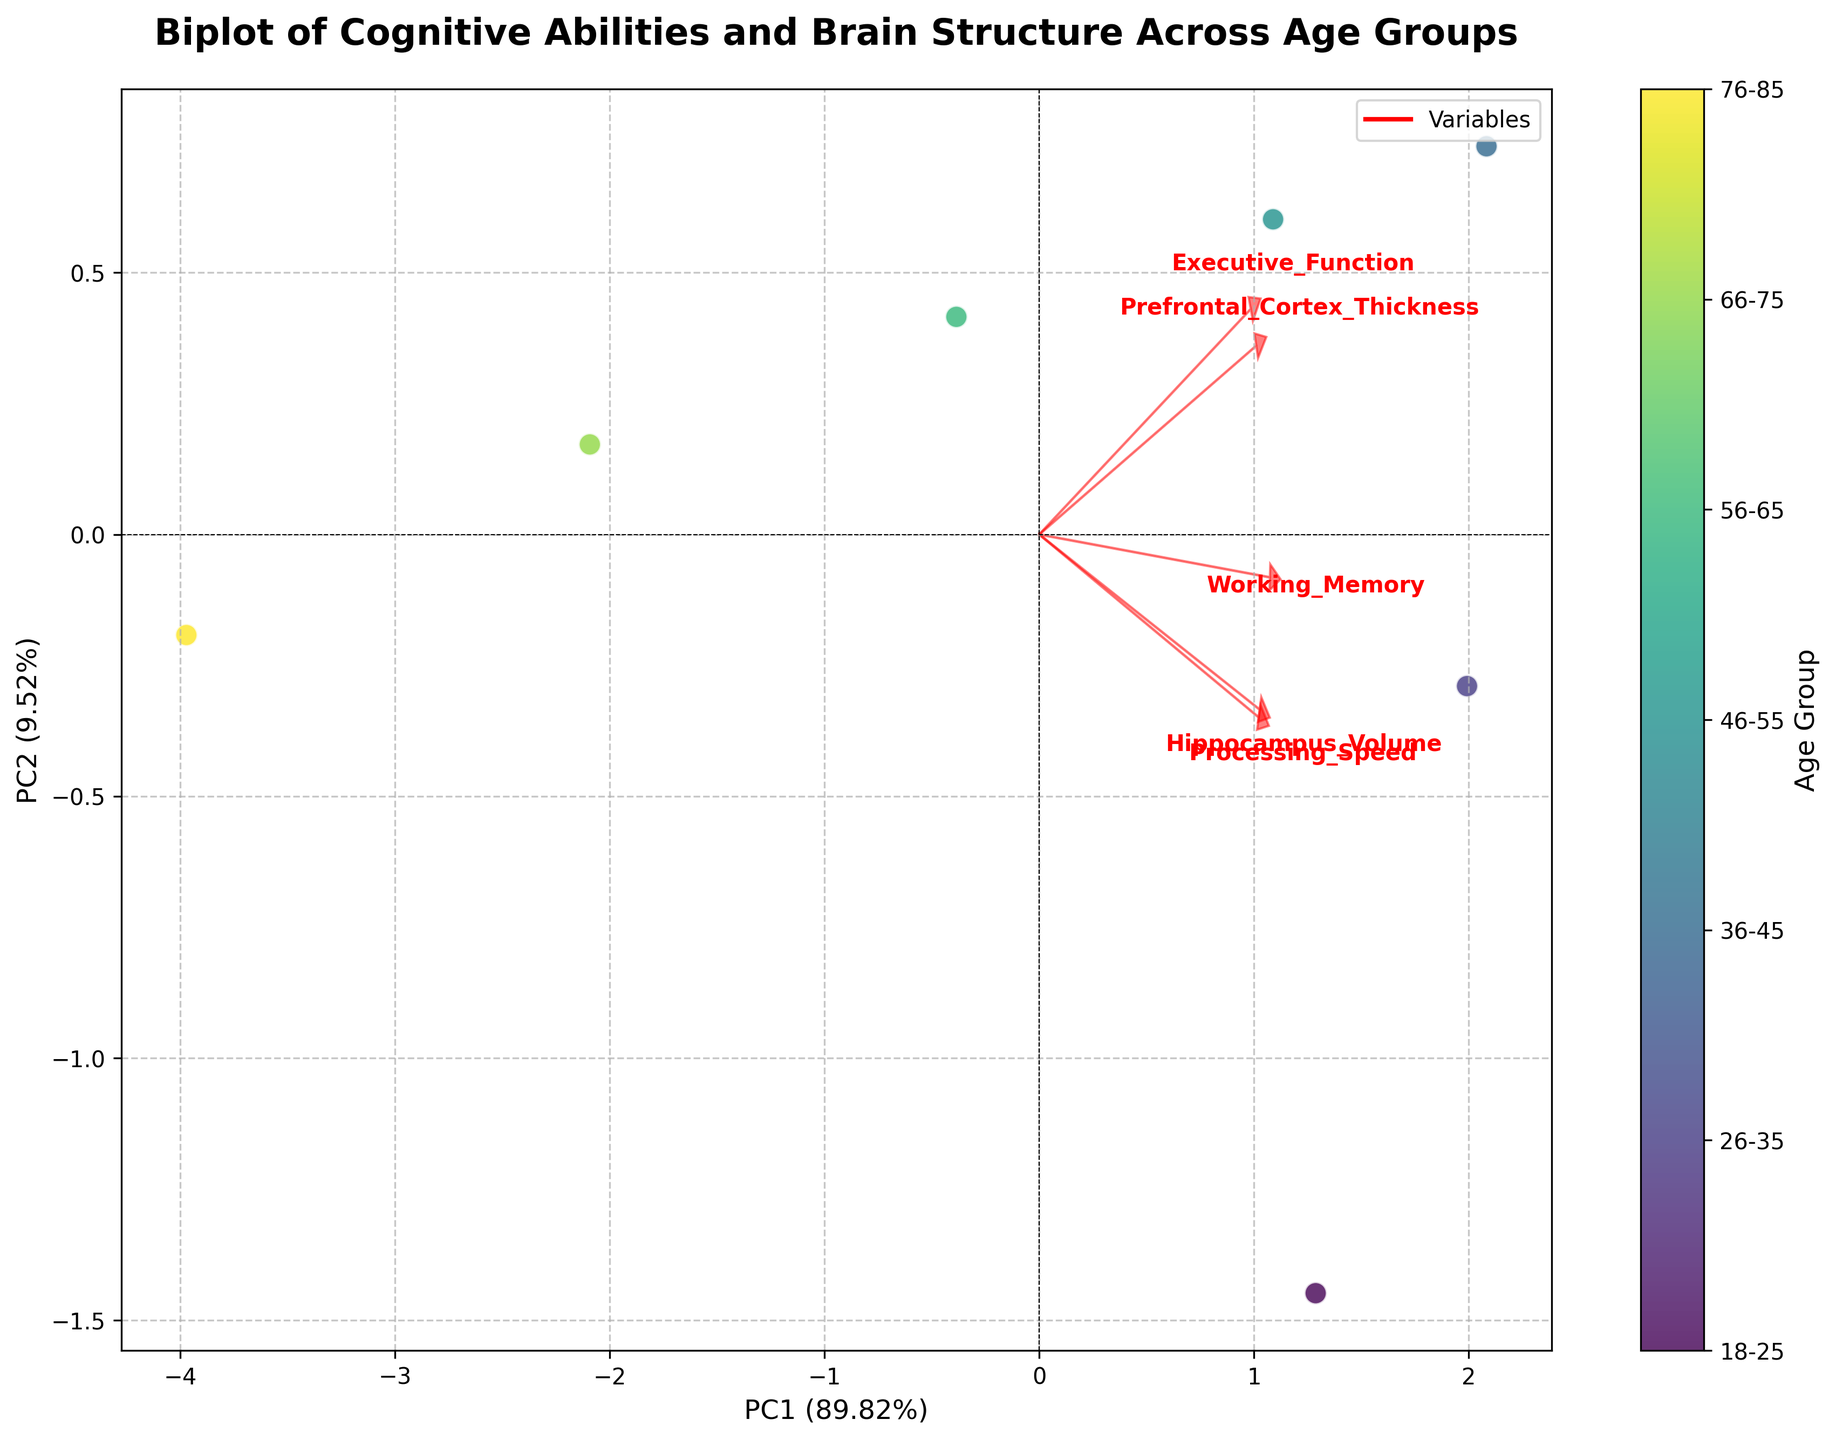What does the title of the figure indicate? The title provides an overview of what the figure is representing. It indicates that the figure compares cognitive abilities and brain structure across different age groups using a biplot.
Answer: Comparison of Cognitive Abilities and Brain Structure Across Age Groups How many age groups are illustrated in the figure? By observing the data points and the color bar, one can notice distinct markers for each age group. There are 7 different age groups represented in the color bar.
Answer: 7 Which age group is represented by the highest data point along PC1? By examining the position of the data points along the x-axis (PC1), we see that the data point farthest to the right represents the age group 26-35.
Answer: 26-35 What percentage of variance is explained by PC1? The x-axis title, PC1, provides the percentage of variance explained. By reading this value, we find that PC1 explains 48.6% of the variance in the data.
Answer: 48.6% For which variables are the loadings most aligned with PC2? The loadings are depicted as red arrows. The variables whose arrows point mostly in the vertical direction are aligned with PC2. Observing the red arrows, we see "Processing_Speed" and "Executive_Function" point more vertically, aligning with PC2.
Answer: Processing Speed, Executive Function Which age group has the smallest prefrontal cortex thickness? From the list of variables, "Prefrontal_Cortex_Thickness" is a key variable. Observing associated arrows and comparing with the color-coded markers, the age group 76-85 is related to the smallest thickness.
Answer: 76-85 Which variable's line is almost horizontal and thus correlates most with PC1? By scrutinizing the red arrows, "Working_Memory" appears the most horizontal, indicating its higher correlation with PC1.
Answer: Working Memory How do hippocampus volume trends discern between younger and older age groups? Younger age groups are placed higher along PC2, where the arrow for "Hippocampus_Volume" points more. Older groups, lower in PC2, show reduced values, aligning the directions. Thus, hippocampus volume decreases with age.
Answer: Decreases with age Compare the executive function across the age groups. Which two age groups have the closest values? "Executive_Function" arrow suggests points clustered in the middle. Observing color-coded position within PC1 and PC2 marks the closest values are evident for age groups 36-45 and 46-55.
Answer: 36-45 and 46-55 How does the variability captured by PC2 compare to PC1? The percentage of variance explained by PC2 can be found in the label on the y-axis, which is 19.3%. Comparing this with PC1 (48.6%), PC2 captures substantially less variability.
Answer: PC2 captures less 